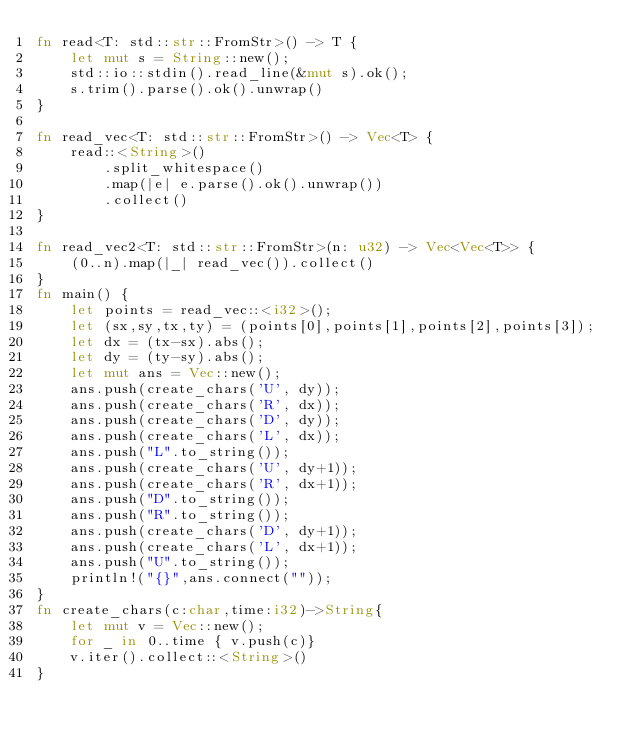Convert code to text. <code><loc_0><loc_0><loc_500><loc_500><_Rust_>fn read<T: std::str::FromStr>() -> T {
    let mut s = String::new();
    std::io::stdin().read_line(&mut s).ok();
    s.trim().parse().ok().unwrap()
}

fn read_vec<T: std::str::FromStr>() -> Vec<T> {
    read::<String>()
        .split_whitespace()
        .map(|e| e.parse().ok().unwrap())
        .collect()
}

fn read_vec2<T: std::str::FromStr>(n: u32) -> Vec<Vec<T>> {
    (0..n).map(|_| read_vec()).collect()
}
fn main() {
    let points = read_vec::<i32>();
    let (sx,sy,tx,ty) = (points[0],points[1],points[2],points[3]);
    let dx = (tx-sx).abs();
    let dy = (ty-sy).abs();
    let mut ans = Vec::new();
    ans.push(create_chars('U', dy));
    ans.push(create_chars('R', dx));
    ans.push(create_chars('D', dy));
    ans.push(create_chars('L', dx));
    ans.push("L".to_string());
    ans.push(create_chars('U', dy+1));
    ans.push(create_chars('R', dx+1));
    ans.push("D".to_string());
    ans.push("R".to_string());
    ans.push(create_chars('D', dy+1));
    ans.push(create_chars('L', dx+1));
    ans.push("U".to_string());
    println!("{}",ans.connect(""));
}
fn create_chars(c:char,time:i32)->String{
    let mut v = Vec::new();
    for _ in 0..time { v.push(c)}
    v.iter().collect::<String>()
}</code> 